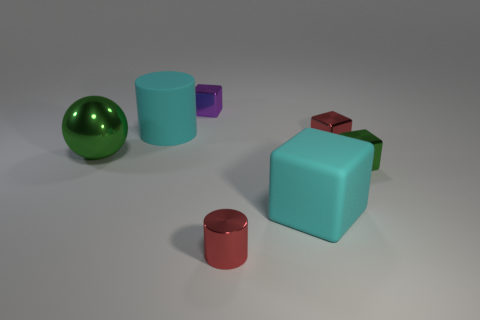Is there anything else that has the same material as the purple thing?
Ensure brevity in your answer.  Yes. Are there more green metal blocks that are behind the big block than purple metallic blocks that are to the right of the tiny purple shiny thing?
Provide a succinct answer. Yes. There is a big object that is the same material as the tiny green block; what shape is it?
Ensure brevity in your answer.  Sphere. How many other objects are there of the same shape as the big metallic object?
Your answer should be compact. 0. What is the shape of the rubber thing that is in front of the tiny red cube?
Your answer should be compact. Cube. The big ball is what color?
Your answer should be very brief. Green. How many other things are the same size as the green sphere?
Keep it short and to the point. 2. There is a small red thing that is in front of the tiny metal cube that is in front of the large ball; what is it made of?
Ensure brevity in your answer.  Metal. Does the purple thing have the same size as the rubber thing to the right of the purple shiny object?
Offer a very short reply. No. Is there a tiny rubber cylinder of the same color as the big cube?
Your response must be concise. No. 